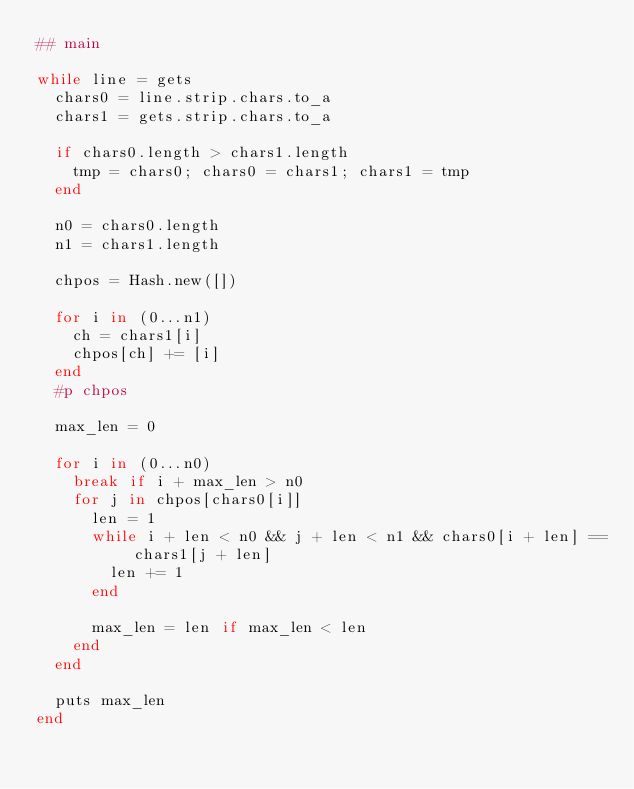<code> <loc_0><loc_0><loc_500><loc_500><_Ruby_>## main

while line = gets
  chars0 = line.strip.chars.to_a
  chars1 = gets.strip.chars.to_a

  if chars0.length > chars1.length
    tmp = chars0; chars0 = chars1; chars1 = tmp
  end

  n0 = chars0.length
  n1 = chars1.length

  chpos = Hash.new([])

  for i in (0...n1)
    ch = chars1[i]
    chpos[ch] += [i]
  end
  #p chpos

  max_len = 0

  for i in (0...n0)
    break if i + max_len > n0
    for j in chpos[chars0[i]]
      len = 1
      while i + len < n0 && j + len < n1 && chars0[i + len] == chars1[j + len]
        len += 1
      end

      max_len = len if max_len < len
    end
  end

  puts max_len
end</code> 